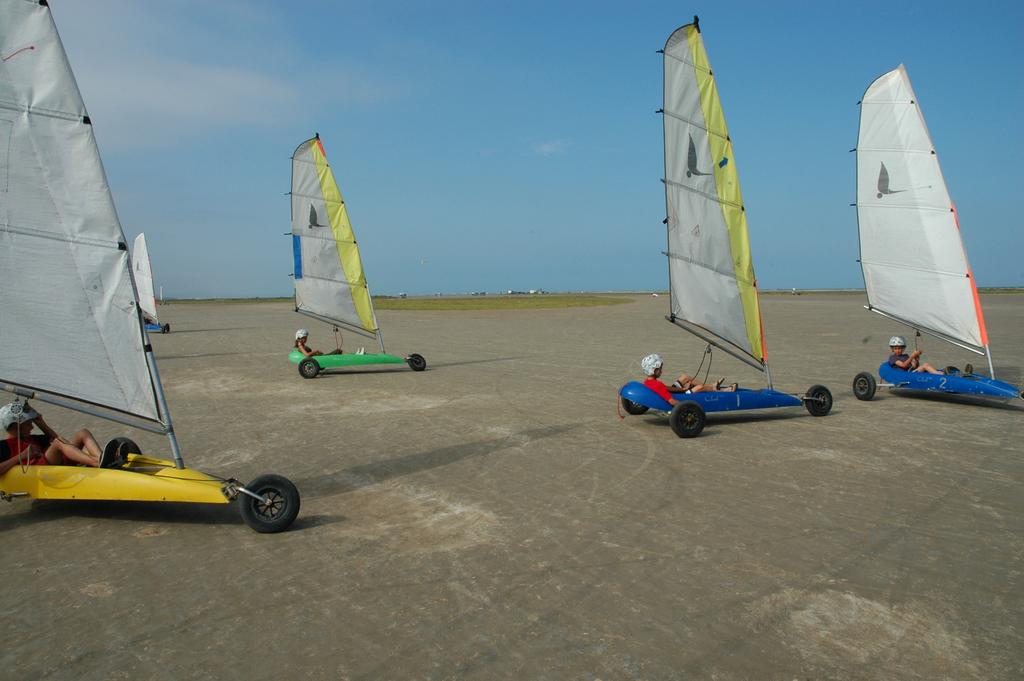Who or what is present in the image? There are people in the image. What are the people wearing? The people are wearing helmets. What activity are the people engaged in? The people are land-sailing. What can be seen in the background of the image? There is sky visible in the background of the image. Can you describe the zephyr that is blowing through the window in the image? There is no zephyr or window present in the image; it features people wearing helmets and land-sailing with the sky visible in the background. 